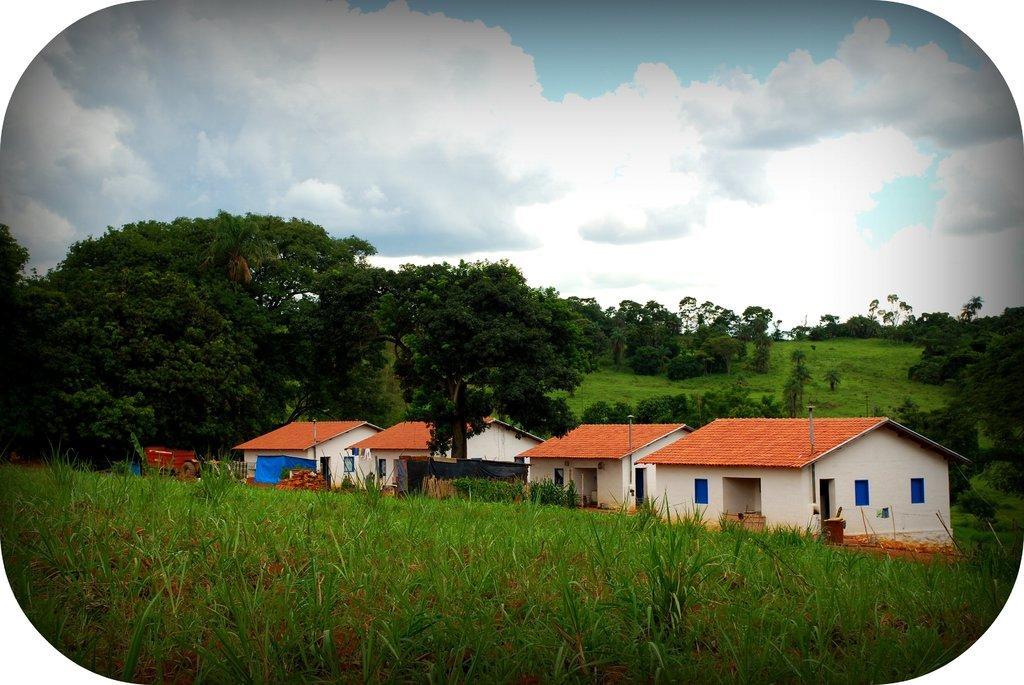Could you give a brief overview of what you see in this image? In this image I can see the plants. To the side of the plants there are houses with the roof. And the roof is in brown color. In the background there are many trees, clouds and the sky. 